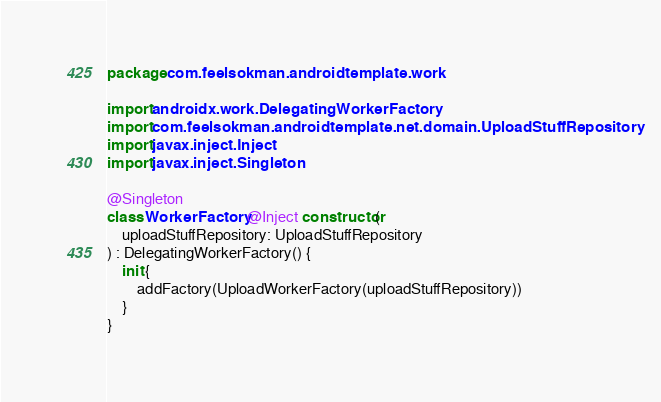<code> <loc_0><loc_0><loc_500><loc_500><_Kotlin_>package com.feelsokman.androidtemplate.work

import androidx.work.DelegatingWorkerFactory
import com.feelsokman.androidtemplate.net.domain.UploadStuffRepository
import javax.inject.Inject
import javax.inject.Singleton

@Singleton
class WorkerFactory @Inject constructor(
    uploadStuffRepository: UploadStuffRepository
) : DelegatingWorkerFactory() {
    init {
        addFactory(UploadWorkerFactory(uploadStuffRepository))
    }
}
</code> 